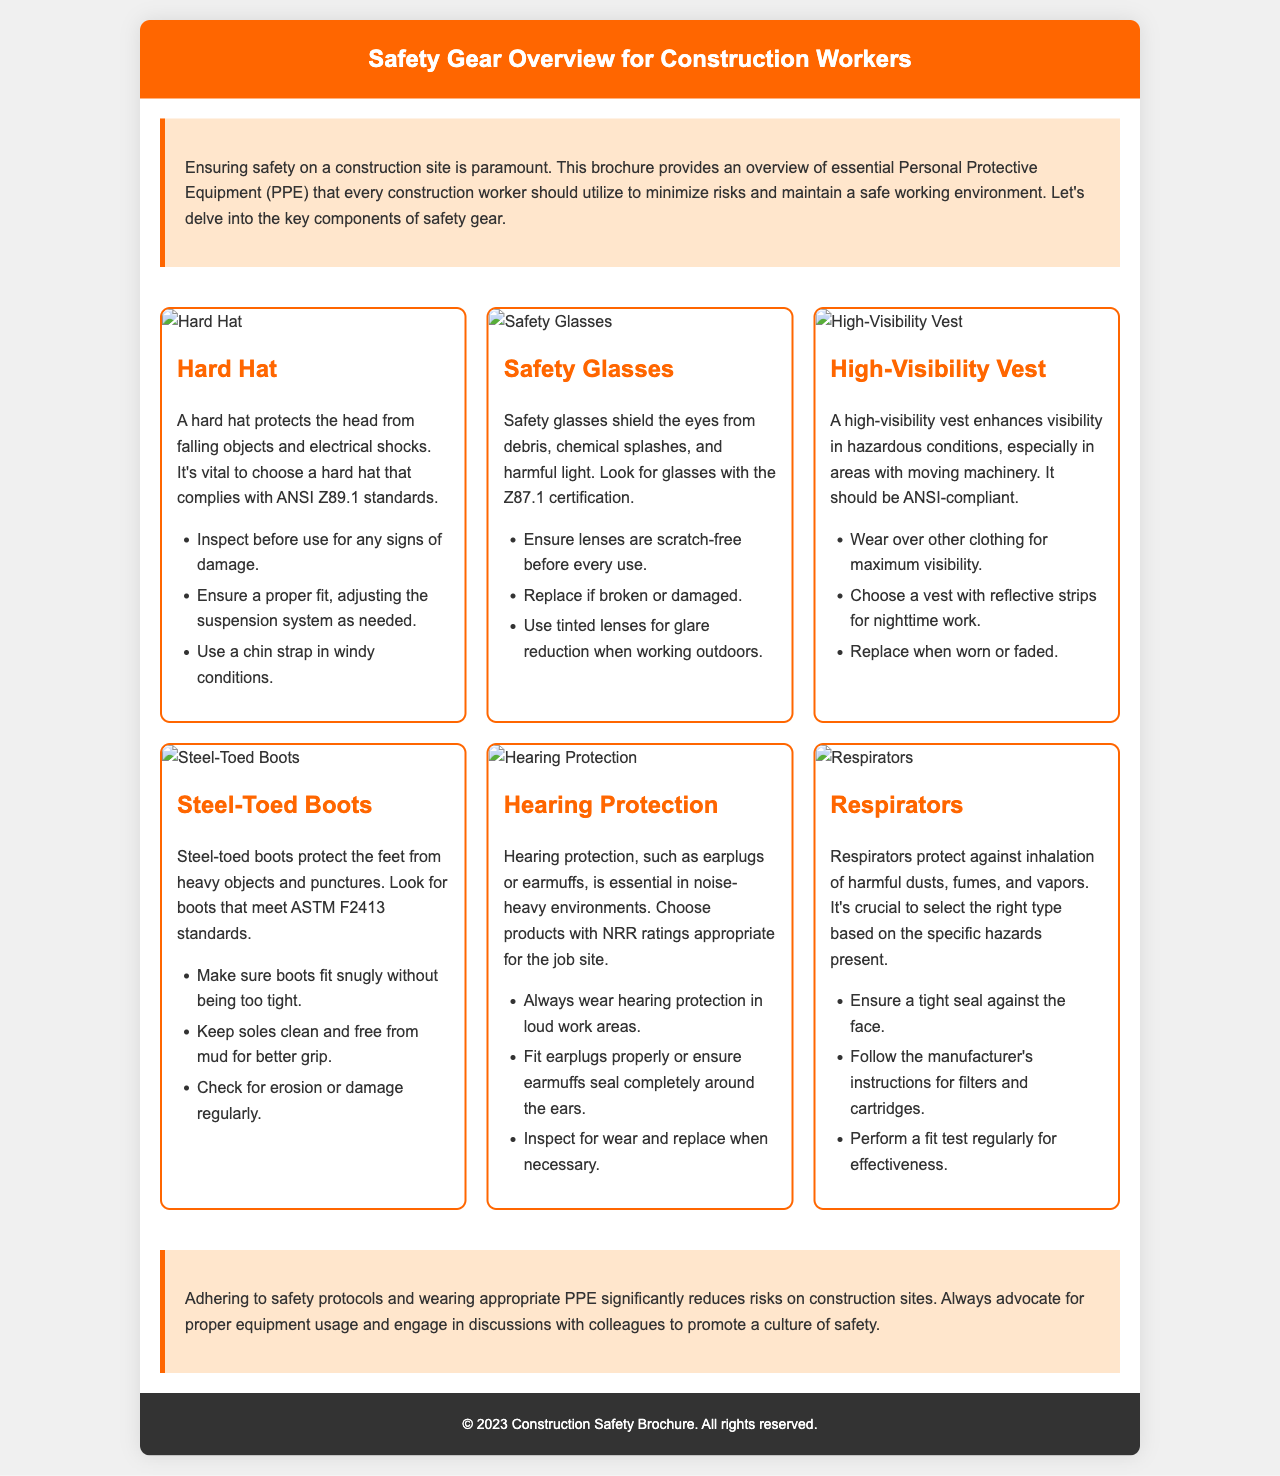What is the title of the brochure? The title of the brochure is prominently displayed at the top of the document.
Answer: Safety Gear Overview for Construction Workers What type of gear protects against falling objects? It refers to a specific type of protection mentioned under the documentation.
Answer: Hard Hat What certification should safety glasses have? The certification is highlighted as an important feature; it specifies the required standard.
Answer: Z87.1 What should you do before using safety glasses? This action is a safety precaution listed in the guidelines.
Answer: Ensure lenses are scratch-free What does the high-visibility vest enhance? The brochure specifies the key purpose of wearing this item in hazardous conditions.
Answer: Visibility What standard should steel-toed boots meet? This information details the compliance necessary for this type of gear.
Answer: ASTM F2413 What should you do regularly to your respirators? The document advises this action as a part of maintenance for effectiveness.
Answer: Perform a fit test What is the significance of the introduction section? This part of the brochure sets the context for the equipment discussed throughout.
Answer: It emphasizes safety importance How should hearing protection fit? This describes the importance of proper usage for effectiveness mentioned in the guidelines.
Answer: Seal completely around the ears 